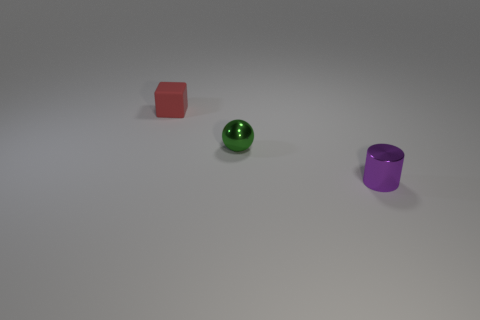Add 3 big cylinders. How many objects exist? 6 Subtract all cylinders. How many objects are left? 2 Subtract 0 red cylinders. How many objects are left? 3 Subtract all red rubber things. Subtract all tiny green metallic spheres. How many objects are left? 1 Add 3 small blocks. How many small blocks are left? 4 Add 3 tiny blocks. How many tiny blocks exist? 4 